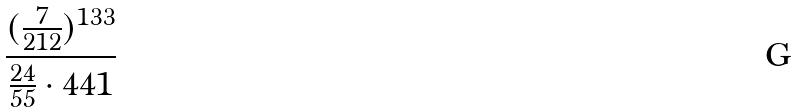Convert formula to latex. <formula><loc_0><loc_0><loc_500><loc_500>\frac { ( \frac { 7 } { 2 1 2 } ) ^ { 1 3 3 } } { \frac { 2 4 } { 5 5 } \cdot 4 4 1 }</formula> 